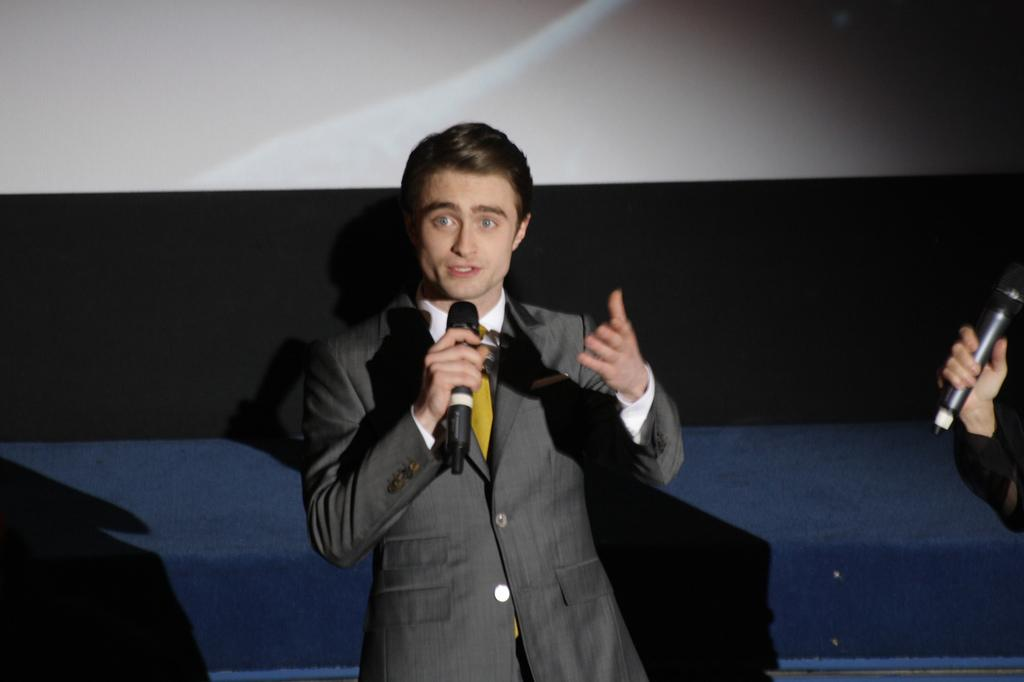What is the main subject of the image? There is a man standing in the middle of the image. What is the man in the middle doing? The man in the middle is holding a microphone and talking. Are there any other people in the image? Yes, there is another man standing at the bottom right side of the image. What is the man at the bottom right side doing? The man at the bottom right side is holding a microphone. What type of feast is being prepared in the image? There is no feast being prepared in the image; it features two men holding microphones. What kind of art can be seen in the image? There is no art present in the image; it features two men holding microphones. 